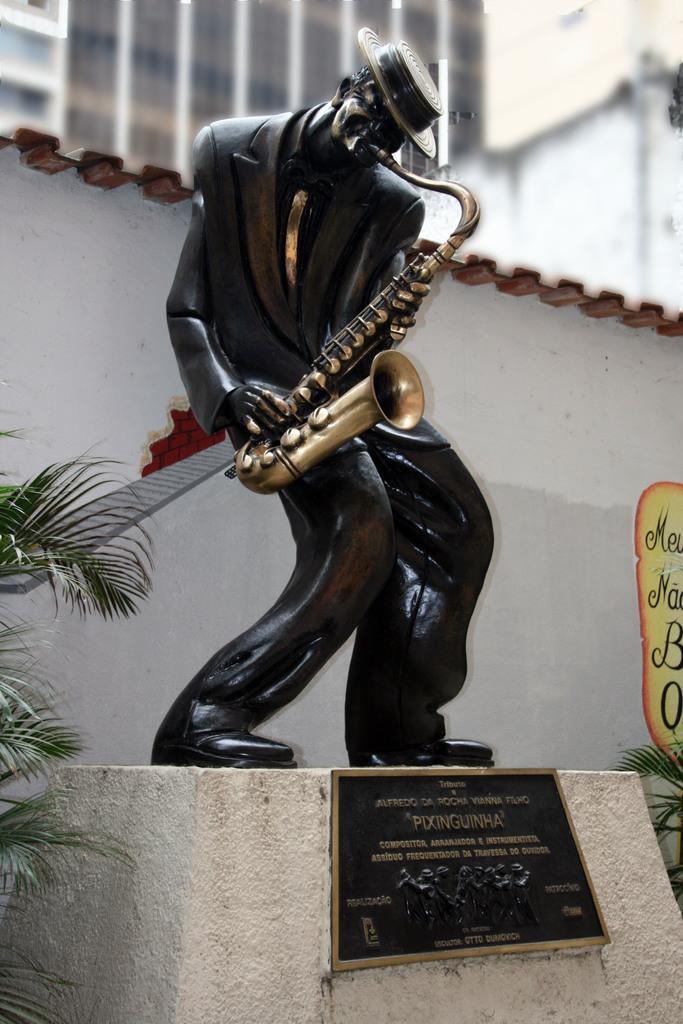In one or two sentences, can you explain what this image depicts? In this image there is a sculpture of person playing music instrument, behind that there is a building and plant. 